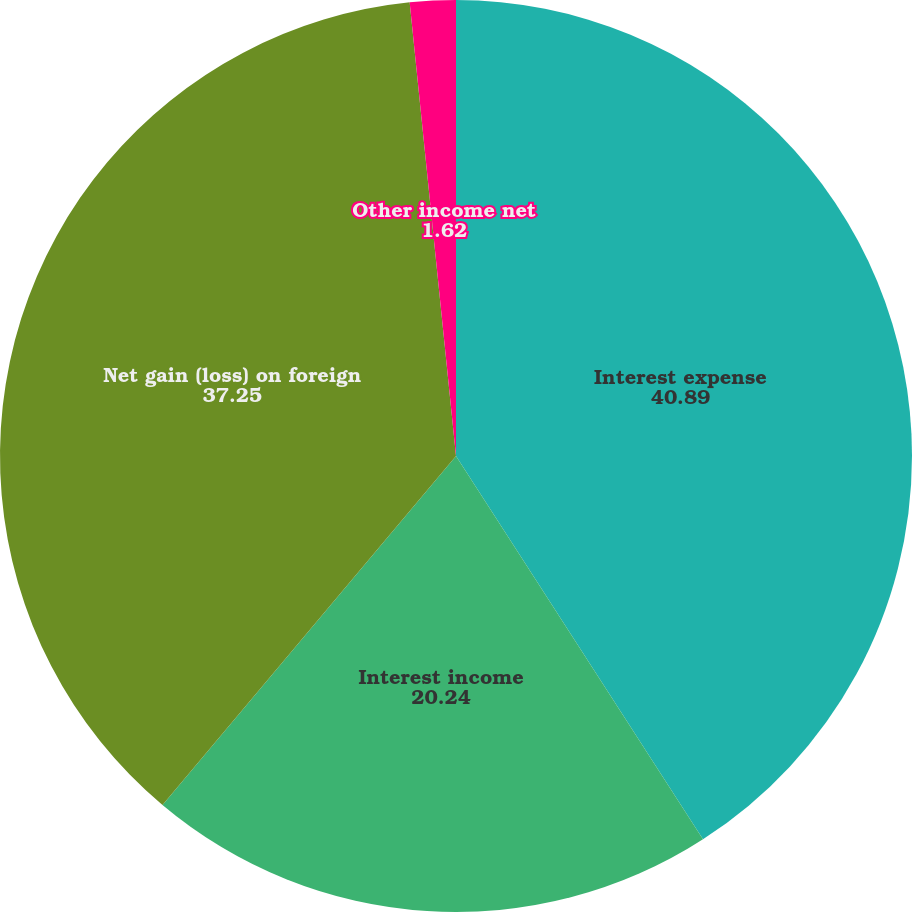Convert chart to OTSL. <chart><loc_0><loc_0><loc_500><loc_500><pie_chart><fcel>Interest expense<fcel>Interest income<fcel>Net gain (loss) on foreign<fcel>Other income net<nl><fcel>40.89%<fcel>20.24%<fcel>37.25%<fcel>1.62%<nl></chart> 